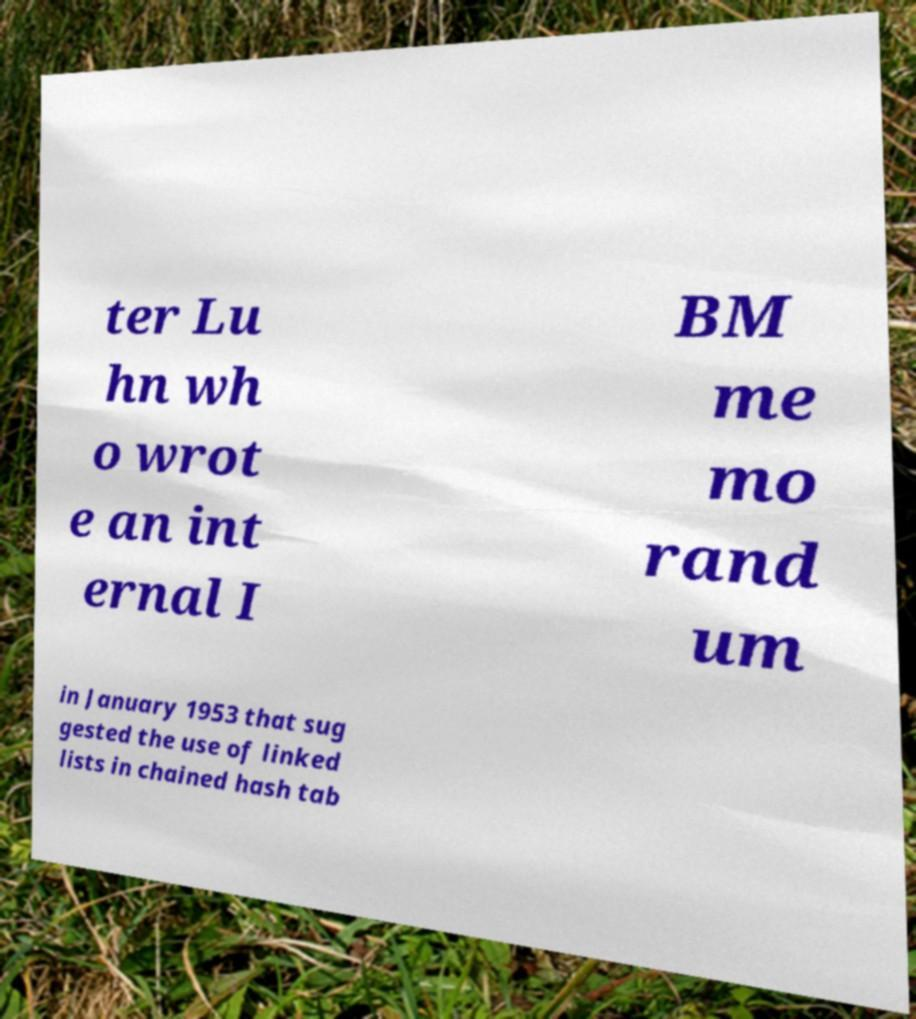There's text embedded in this image that I need extracted. Can you transcribe it verbatim? ter Lu hn wh o wrot e an int ernal I BM me mo rand um in January 1953 that sug gested the use of linked lists in chained hash tab 